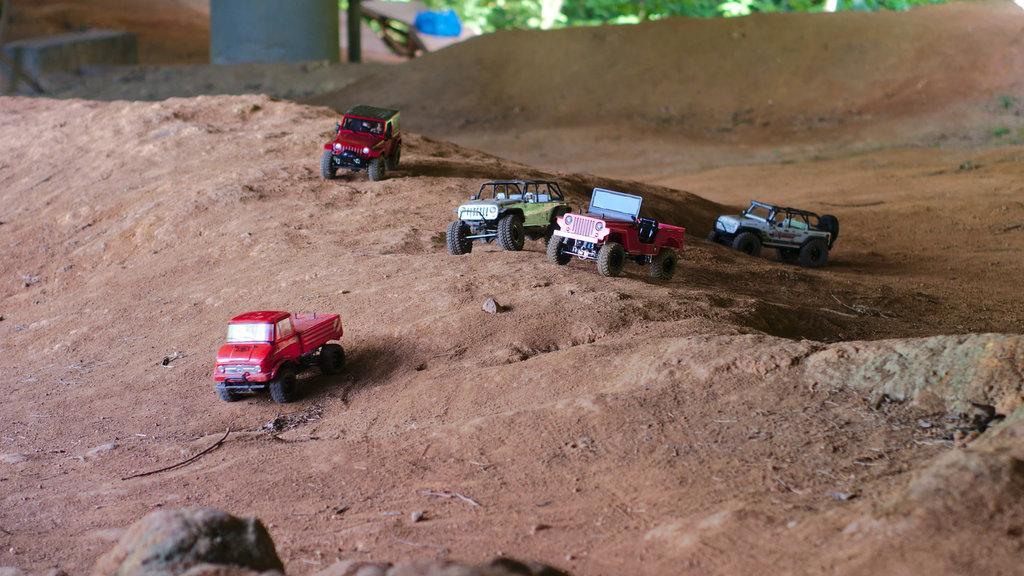Please provide a concise description of this image. In this image we can see a few vehicles on the ground, there are some trees, pole and some other objects on the ground. 